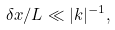<formula> <loc_0><loc_0><loc_500><loc_500>\delta x / L \ll | k | ^ { - 1 } ,</formula> 